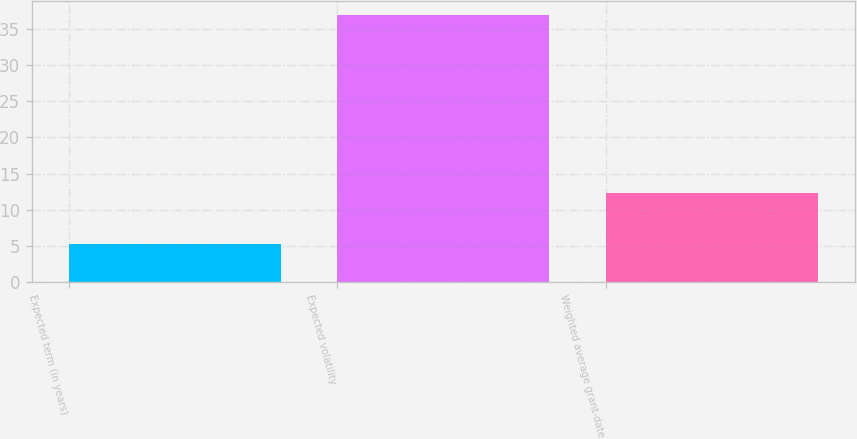Convert chart to OTSL. <chart><loc_0><loc_0><loc_500><loc_500><bar_chart><fcel>Expected term (in years)<fcel>Expected volatility<fcel>Weighted average grant-date<nl><fcel>5.21<fcel>37<fcel>12.33<nl></chart> 